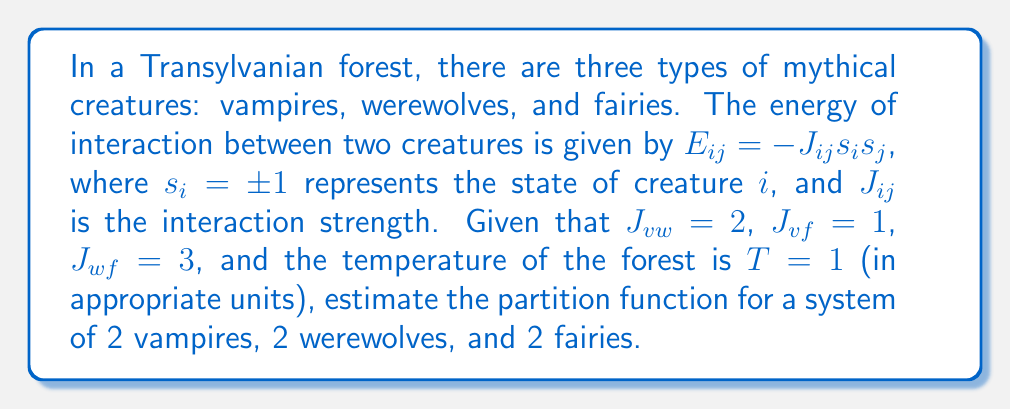Show me your answer to this math problem. To estimate the partition function, we'll follow these steps:

1) The partition function is given by:
   $$Z = \sum_{\text{all states}} e^{-\beta E}$$
   where $\beta = \frac{1}{k_BT}$ and $E$ is the total energy of the system.

2) In our case, $\beta = 1$ since $T = 1$ in the given units.

3) The total energy of the system is the sum of all pairwise interactions:
   $$E = -\sum_{i<j} J_{ij}s_is_j$$

4) We have 6 creatures in total, so there are $2^6 = 64$ possible states.

5) For each state, we need to calculate:
   $$E = -2s_v1s_v2 - 2s_v1s_w1 - 2s_v1s_w2 - s_v1s_f1 - s_v1s_f2 - 2s_v2s_w1 - 2s_v2s_w2 - s_v2s_f1 - s_v2s_f2 - 3s_w1s_f1 - 3s_w1s_f2 - 3s_w2s_f1 - 3s_w2s_f2 - 2s_w1s_w2 - s_f1s_f2$$

6) For each of the 64 states, we calculate $e^{-E}$ and sum these values.

7) Due to the complexity, we would typically use a computer to calculate this sum exactly. However, for an estimate, we can consider the dominant contributions:

   - The lowest energy state (all creatures aligned): $E = -25$, contribution $\approx e^{25}$
   - The highest energy state (all creatures anti-aligned): $E = 25$, contribution $\approx e^{-25}$
   - States with half aligned and half anti-aligned: $E \approx 0$, contribution $\approx 1$ (there are many of these)

8) The partition function will be dominated by the lowest energy state, so we can estimate:
   $$Z \approx e^{25} + \text{(contributions from other states)} \approx 10^{11}$$

This is a rough estimate, as the actual value would require summing all 64 states.
Answer: $Z \approx 10^{11}$ 